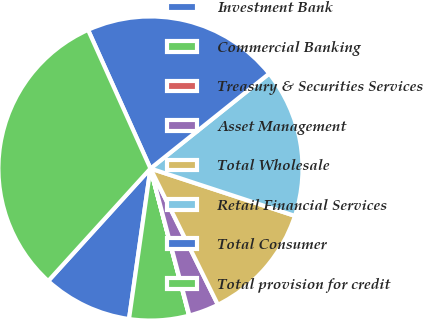<chart> <loc_0><loc_0><loc_500><loc_500><pie_chart><fcel>Investment Bank<fcel>Commercial Banking<fcel>Treasury & Securities Services<fcel>Asset Management<fcel>Total Wholesale<fcel>Retail Financial Services<fcel>Total Consumer<fcel>Total provision for credit<nl><fcel>9.49%<fcel>6.34%<fcel>0.04%<fcel>3.19%<fcel>12.64%<fcel>15.78%<fcel>21.0%<fcel>31.53%<nl></chart> 